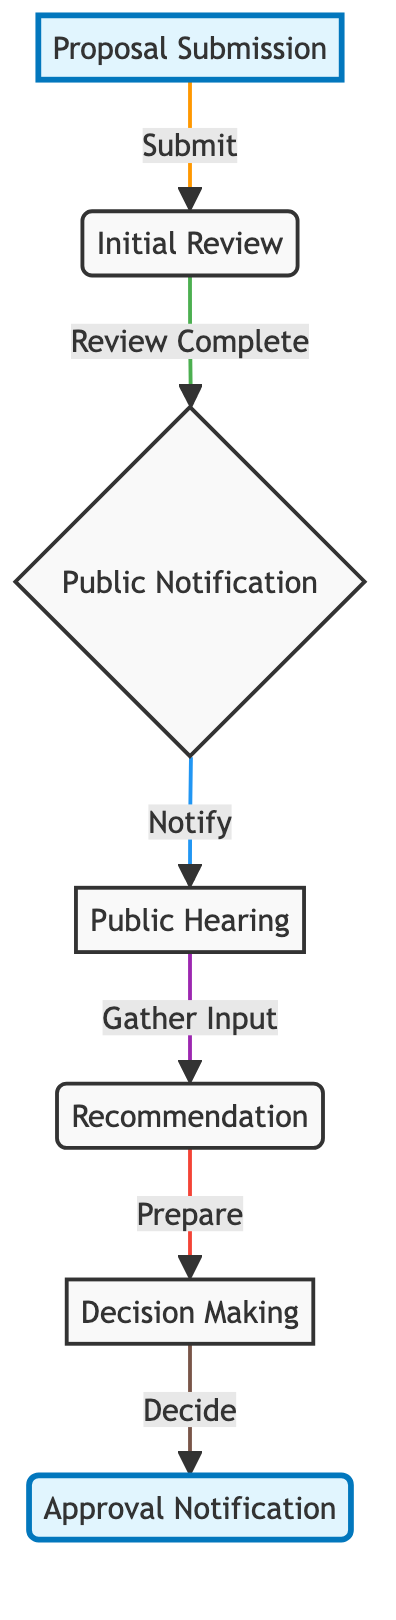What is the first step in the urban zoning approval process? The first step in the process is "Proposal Submission," which is where developers or local authorities submit their urban zoning proposals.
Answer: Proposal Submission How many main steps are there in this flow chart? The flow chart contains a total of six main steps that are interconnected, starting from "Proposal Submission" and ending with "Approval Notification."
Answer: Six What happens after the initial review is completed? After the "Initial Review," the flow chart indicates that the next step is "Public Notification," where the public is informed about the proposed zoning changes for feedback.
Answer: Public Notification Which step gathers opinions from stakeholders and the community? The step that gathers opinions is "Public Hearing," where stakeholders and the community are invited to express their views regarding the proposed zoning changes.
Answer: Public Hearing What action is taken after gathering input from the public hearing? After gathering input, the next action taken is the preparation of "Recommendation" by the urban planning staff based on the review and public feedback received.
Answer: Recommendation What is the final outcome in the urban zoning approval process? The final outcome is the "Approval Notification," where the final decision is communicated to the applicant and the public.
Answer: Approval Notification What is the relationship between "Public Notification" and "Public Hearing"? "Public Notification" leads to "Public Hearing," indicating that public notification is a prerequisite for conducting the public hearing to gather feedback.
Answer: Leads to Which two steps are highlighted in the flow chart? The highlighted steps are "Proposal Submission" and "Approval Notification," which likely signify their importance in the overall process.
Answer: Proposal Submission and Approval Notification What is the role of urban planning staff in this process? The role of urban planning staff is to prepare recommendations after considering the initial proposal review and the public input given during the public hearing.
Answer: Prepare recommendations 